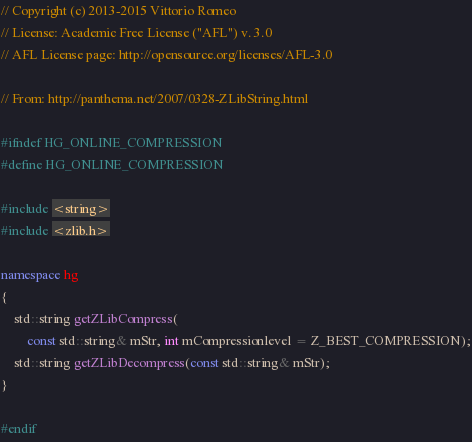Convert code to text. <code><loc_0><loc_0><loc_500><loc_500><_C++_>// Copyright (c) 2013-2015 Vittorio Romeo
// License: Academic Free License ("AFL") v. 3.0
// AFL License page: http://opensource.org/licenses/AFL-3.0

// From: http://panthema.net/2007/0328-ZLibString.html

#ifndef HG_ONLINE_COMPRESSION
#define HG_ONLINE_COMPRESSION

#include <string>
#include <zlib.h>

namespace hg
{
    std::string getZLibCompress(
        const std::string& mStr, int mCompressionlevel = Z_BEST_COMPRESSION);
    std::string getZLibDecompress(const std::string& mStr);
}

#endif
</code> 